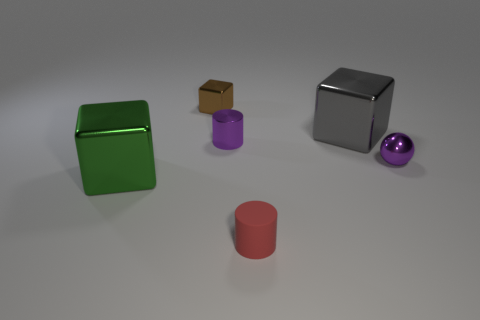Subtract all big blocks. How many blocks are left? 1 Add 2 brown objects. How many objects exist? 8 Subtract 2 cubes. How many cubes are left? 1 Subtract all gray cubes. How many cubes are left? 2 Subtract all cylinders. How many objects are left? 4 Add 5 shiny cylinders. How many shiny cylinders are left? 6 Add 5 matte objects. How many matte objects exist? 6 Subtract 0 blue cylinders. How many objects are left? 6 Subtract all gray cylinders. Subtract all green spheres. How many cylinders are left? 2 Subtract all small red cylinders. Subtract all purple rubber cubes. How many objects are left? 5 